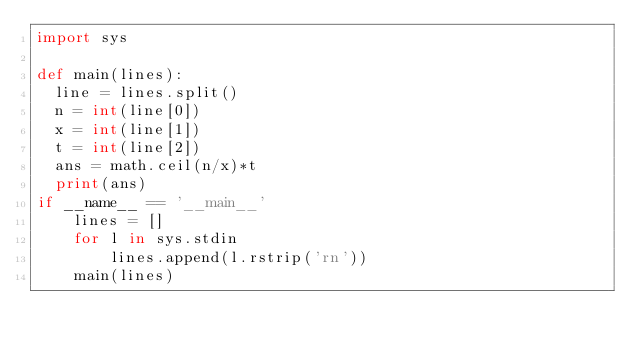<code> <loc_0><loc_0><loc_500><loc_500><_Python_>import sys

def main(lines):
  line = lines.split()
  n = int(line[0])
  x = int(line[1])
  t = int(line[2])
  ans = math.ceil(n/x)*t
  print(ans)
if __name__ == '__main__'
    lines = []
    for l in sys.stdin
        lines.append(l.rstrip('rn'))
    main(lines)
</code> 